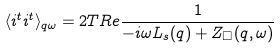Convert formula to latex. <formula><loc_0><loc_0><loc_500><loc_500>\langle { i } ^ { t } { i } ^ { t } \rangle _ { { q } \omega } = 2 T R e \frac { 1 } { - i \omega L _ { s } ( q ) + Z _ { \Box } ( { q } , \omega ) }</formula> 